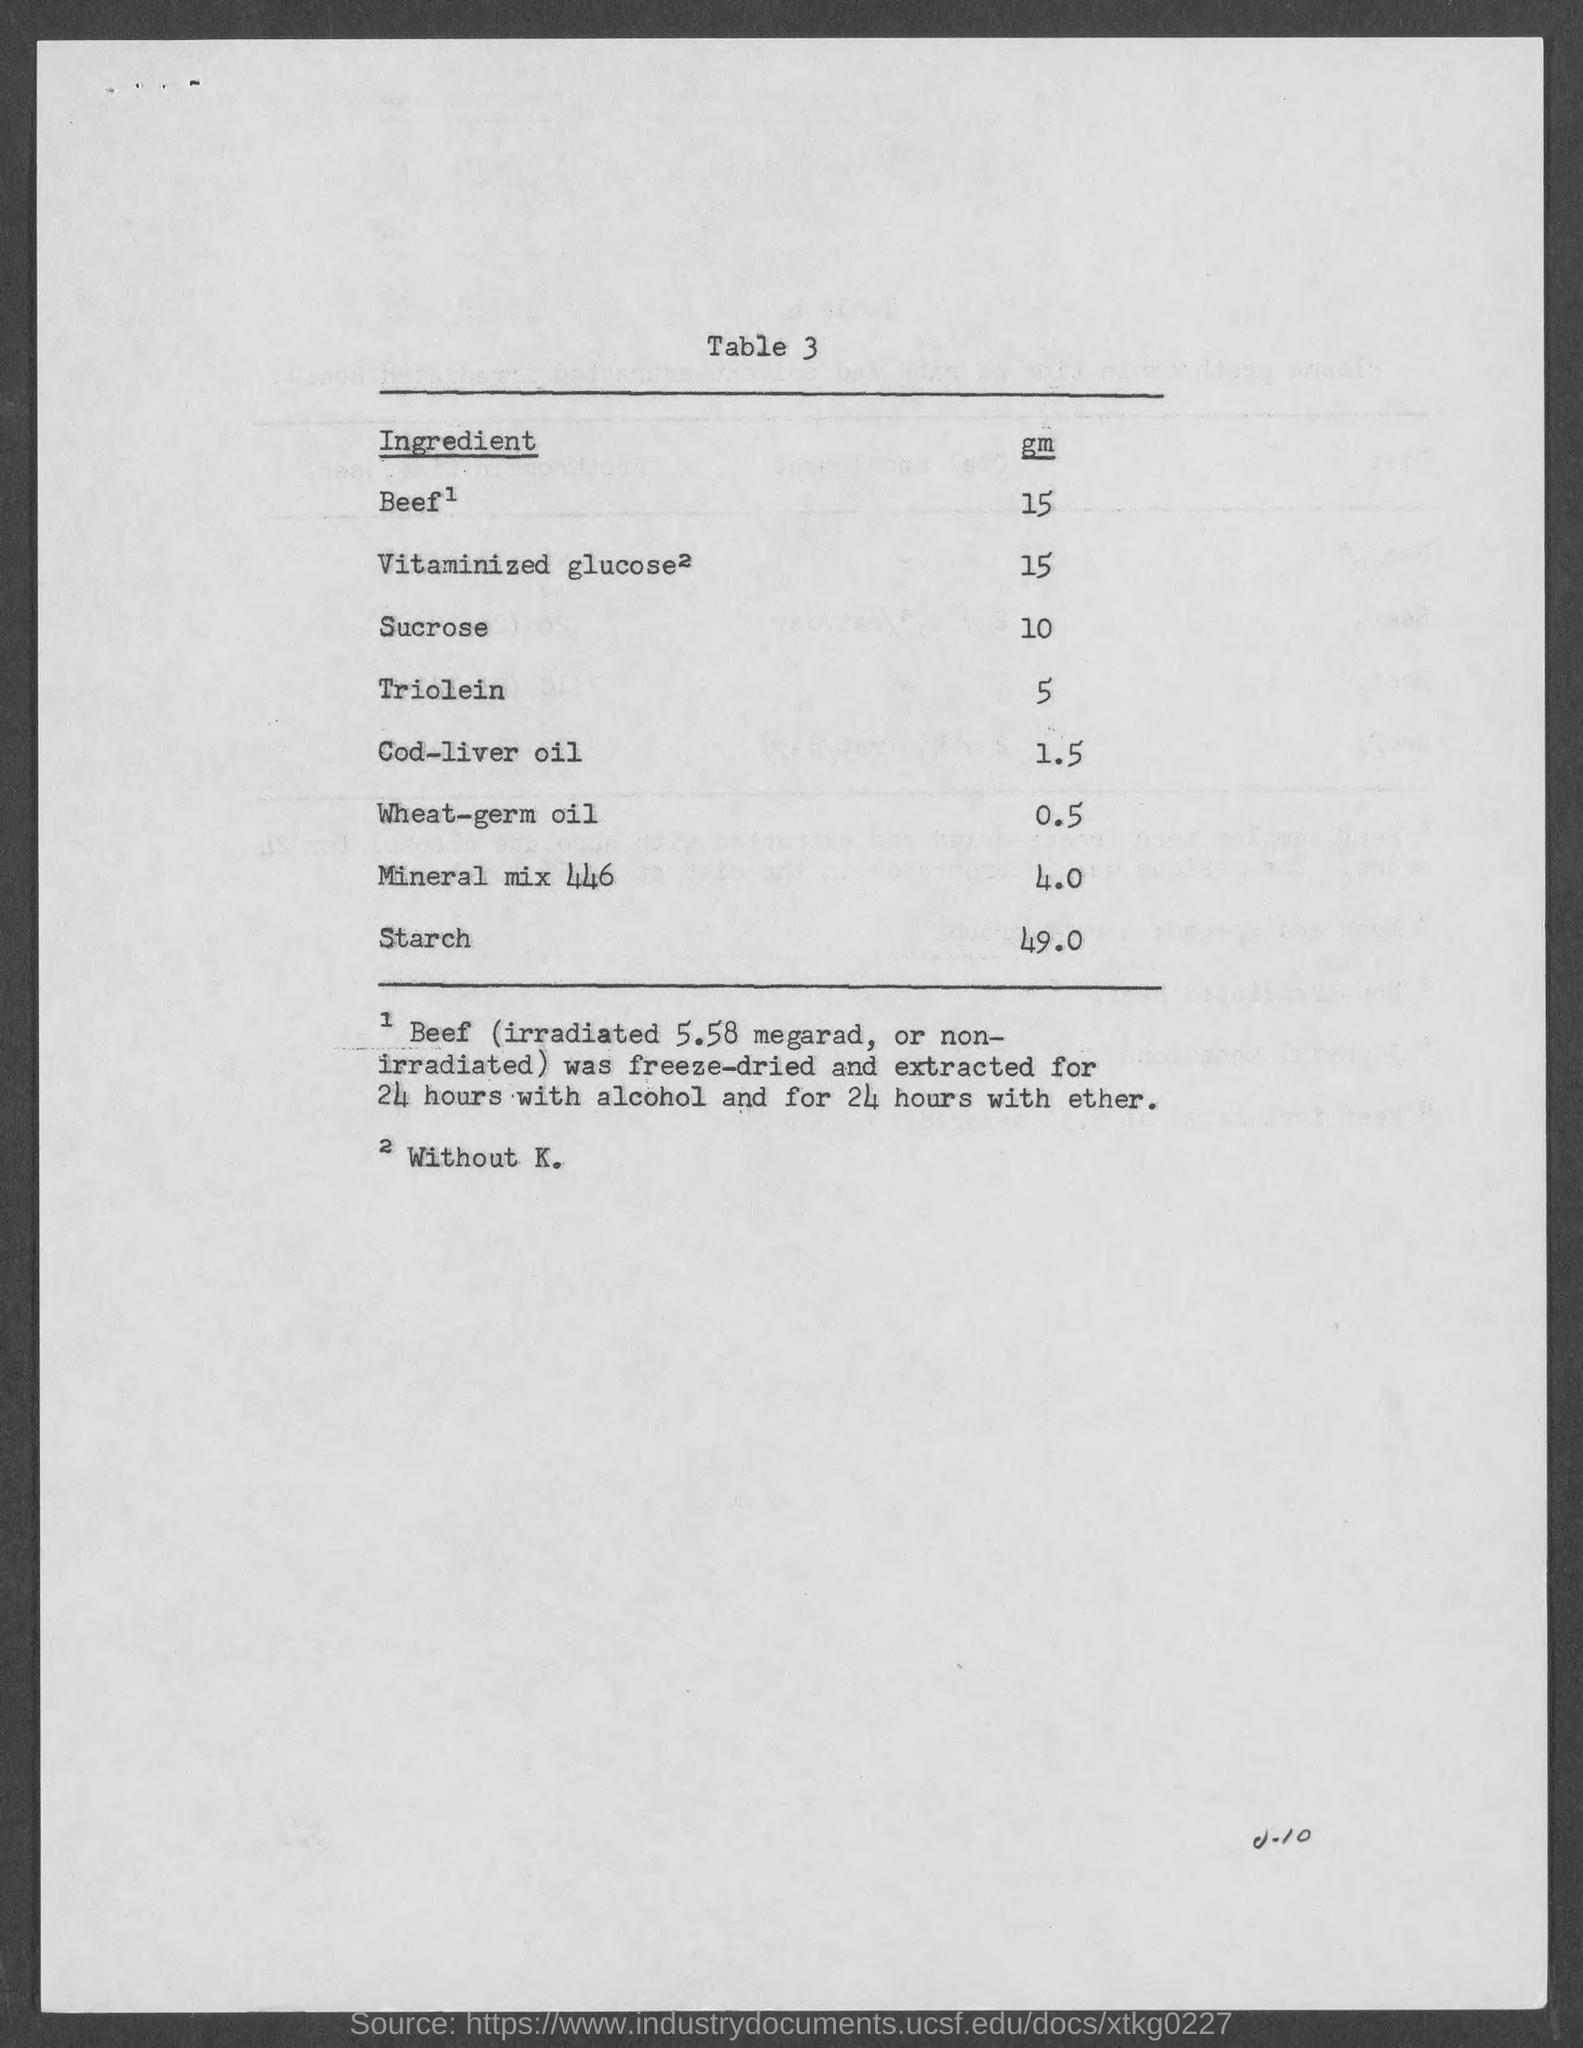What is the table number?
Provide a succinct answer. Table 3. What is the amount of starch?
Provide a short and direct response. 49.0. What is the amount of surcose?
Your response must be concise. 10. Which ingredient is in a large amount?
Give a very brief answer. Starch. Which ingredient is in a small amount?
Your answer should be very brief. Wheat-germ oil. What is the amount of cod-liver oil?
Offer a very short reply. 1.5. 